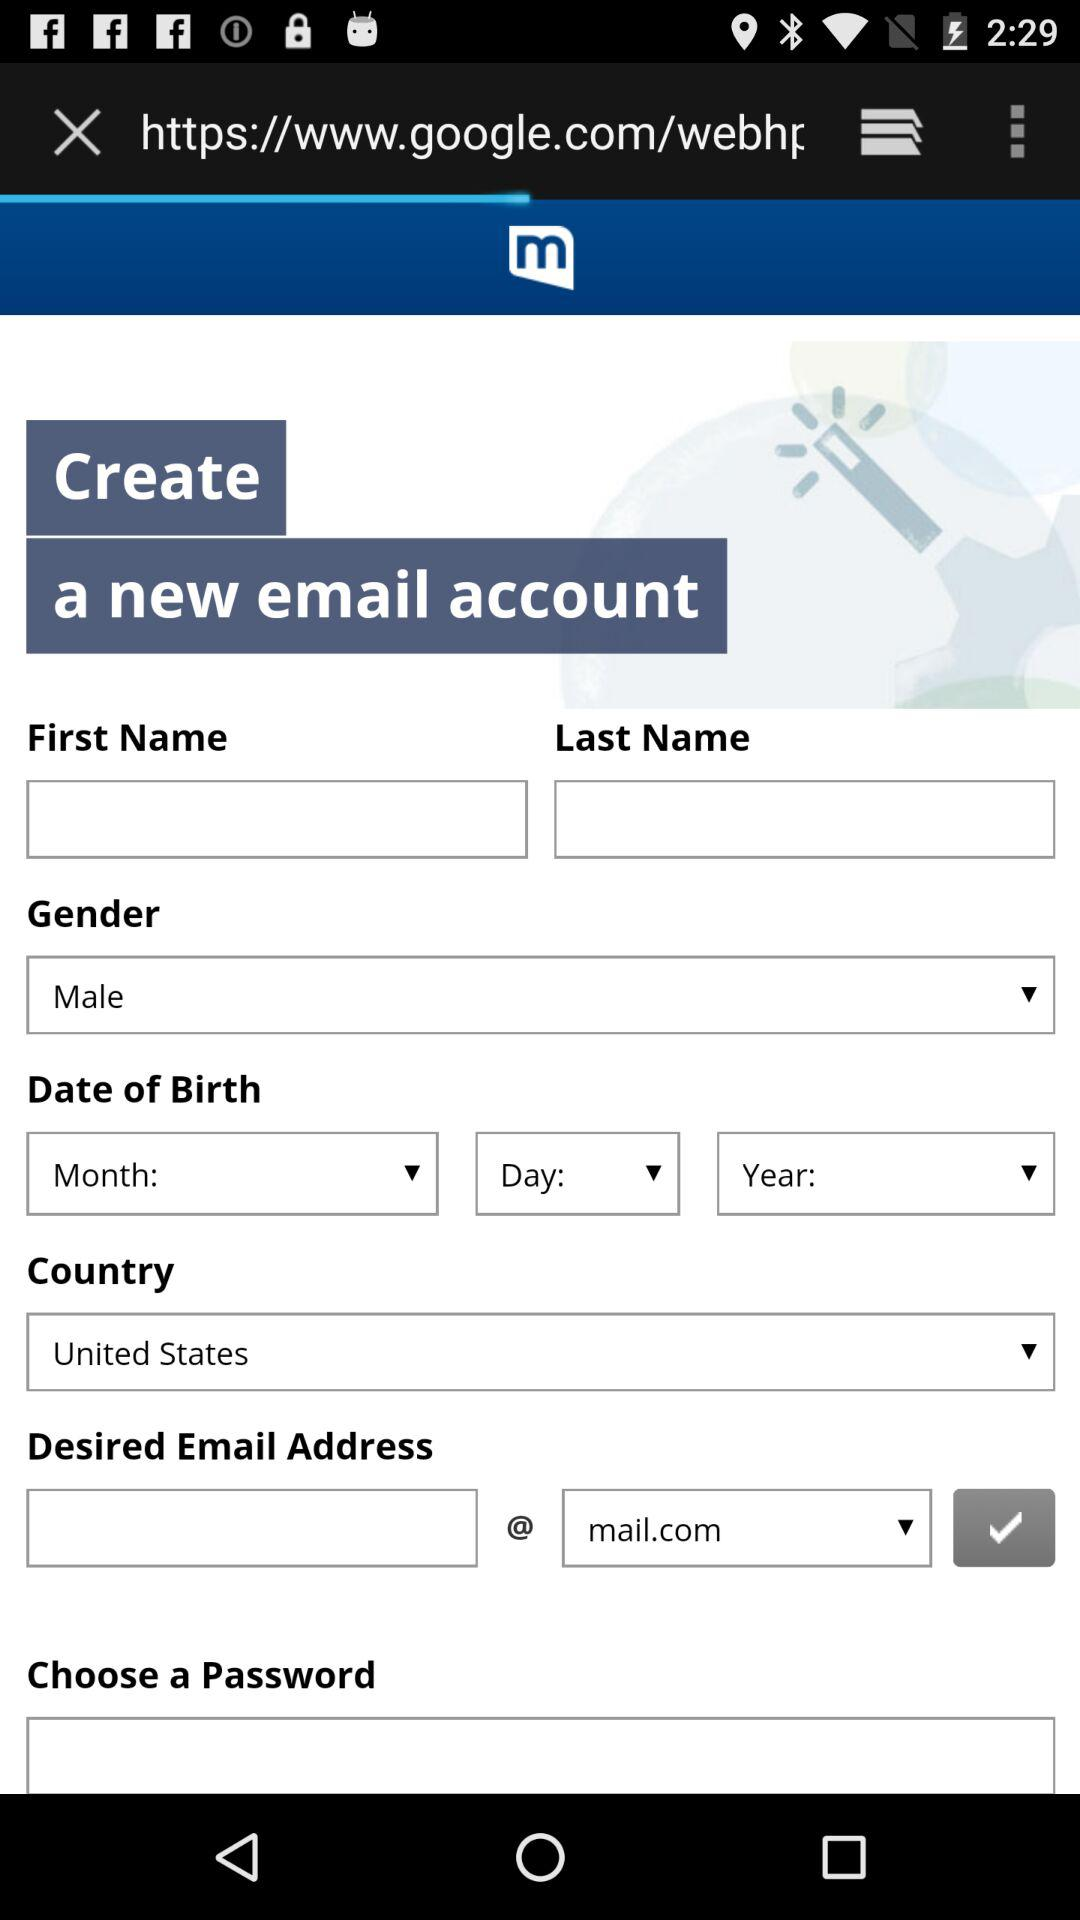Which gender is displayed on the screen? The gender is male. 